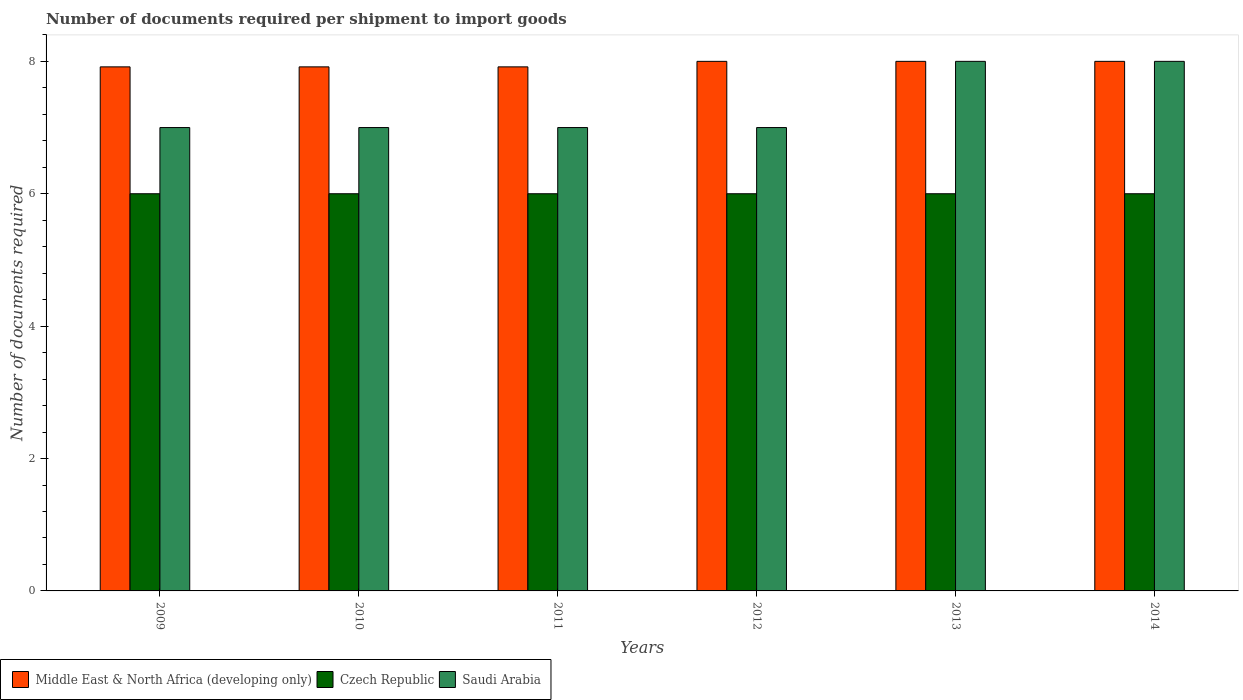How many different coloured bars are there?
Provide a succinct answer. 3. Are the number of bars per tick equal to the number of legend labels?
Your answer should be very brief. Yes. Are the number of bars on each tick of the X-axis equal?
Offer a very short reply. Yes. How many bars are there on the 3rd tick from the right?
Your answer should be very brief. 3. In how many cases, is the number of bars for a given year not equal to the number of legend labels?
Give a very brief answer. 0. What is the number of documents required per shipment to import goods in Middle East & North Africa (developing only) in 2010?
Provide a succinct answer. 7.92. Across all years, what is the maximum number of documents required per shipment to import goods in Middle East & North Africa (developing only)?
Make the answer very short. 8. Across all years, what is the minimum number of documents required per shipment to import goods in Middle East & North Africa (developing only)?
Keep it short and to the point. 7.92. In which year was the number of documents required per shipment to import goods in Czech Republic minimum?
Ensure brevity in your answer.  2009. What is the total number of documents required per shipment to import goods in Saudi Arabia in the graph?
Provide a succinct answer. 44. What is the difference between the number of documents required per shipment to import goods in Middle East & North Africa (developing only) in 2010 and the number of documents required per shipment to import goods in Saudi Arabia in 2009?
Keep it short and to the point. 0.92. What is the average number of documents required per shipment to import goods in Middle East & North Africa (developing only) per year?
Make the answer very short. 7.96. In the year 2011, what is the difference between the number of documents required per shipment to import goods in Middle East & North Africa (developing only) and number of documents required per shipment to import goods in Czech Republic?
Your answer should be compact. 1.92. What is the ratio of the number of documents required per shipment to import goods in Czech Republic in 2010 to that in 2012?
Ensure brevity in your answer.  1. Is the difference between the number of documents required per shipment to import goods in Middle East & North Africa (developing only) in 2009 and 2011 greater than the difference between the number of documents required per shipment to import goods in Czech Republic in 2009 and 2011?
Offer a terse response. No. In how many years, is the number of documents required per shipment to import goods in Saudi Arabia greater than the average number of documents required per shipment to import goods in Saudi Arabia taken over all years?
Make the answer very short. 2. What does the 2nd bar from the left in 2012 represents?
Provide a short and direct response. Czech Republic. What does the 3rd bar from the right in 2012 represents?
Offer a terse response. Middle East & North Africa (developing only). Is it the case that in every year, the sum of the number of documents required per shipment to import goods in Middle East & North Africa (developing only) and number of documents required per shipment to import goods in Czech Republic is greater than the number of documents required per shipment to import goods in Saudi Arabia?
Offer a very short reply. Yes. Are all the bars in the graph horizontal?
Ensure brevity in your answer.  No. Where does the legend appear in the graph?
Keep it short and to the point. Bottom left. How many legend labels are there?
Provide a short and direct response. 3. How are the legend labels stacked?
Your answer should be compact. Horizontal. What is the title of the graph?
Provide a short and direct response. Number of documents required per shipment to import goods. What is the label or title of the X-axis?
Make the answer very short. Years. What is the label or title of the Y-axis?
Your answer should be compact. Number of documents required. What is the Number of documents required in Middle East & North Africa (developing only) in 2009?
Make the answer very short. 7.92. What is the Number of documents required of Czech Republic in 2009?
Provide a short and direct response. 6. What is the Number of documents required of Middle East & North Africa (developing only) in 2010?
Your answer should be very brief. 7.92. What is the Number of documents required of Czech Republic in 2010?
Ensure brevity in your answer.  6. What is the Number of documents required of Middle East & North Africa (developing only) in 2011?
Provide a short and direct response. 7.92. What is the Number of documents required of Czech Republic in 2011?
Your response must be concise. 6. What is the Number of documents required in Middle East & North Africa (developing only) in 2014?
Provide a short and direct response. 8. What is the Number of documents required in Czech Republic in 2014?
Give a very brief answer. 6. Across all years, what is the maximum Number of documents required in Middle East & North Africa (developing only)?
Your response must be concise. 8. Across all years, what is the maximum Number of documents required of Czech Republic?
Offer a terse response. 6. Across all years, what is the minimum Number of documents required in Middle East & North Africa (developing only)?
Offer a terse response. 7.92. What is the total Number of documents required in Middle East & North Africa (developing only) in the graph?
Give a very brief answer. 47.75. What is the total Number of documents required of Czech Republic in the graph?
Keep it short and to the point. 36. What is the total Number of documents required in Saudi Arabia in the graph?
Ensure brevity in your answer.  44. What is the difference between the Number of documents required of Czech Republic in 2009 and that in 2010?
Offer a very short reply. 0. What is the difference between the Number of documents required of Saudi Arabia in 2009 and that in 2010?
Provide a short and direct response. 0. What is the difference between the Number of documents required in Czech Republic in 2009 and that in 2011?
Give a very brief answer. 0. What is the difference between the Number of documents required of Saudi Arabia in 2009 and that in 2011?
Your answer should be compact. 0. What is the difference between the Number of documents required of Middle East & North Africa (developing only) in 2009 and that in 2012?
Ensure brevity in your answer.  -0.08. What is the difference between the Number of documents required of Middle East & North Africa (developing only) in 2009 and that in 2013?
Provide a short and direct response. -0.08. What is the difference between the Number of documents required in Middle East & North Africa (developing only) in 2009 and that in 2014?
Give a very brief answer. -0.08. What is the difference between the Number of documents required of Czech Republic in 2009 and that in 2014?
Keep it short and to the point. 0. What is the difference between the Number of documents required of Saudi Arabia in 2009 and that in 2014?
Provide a succinct answer. -1. What is the difference between the Number of documents required of Czech Republic in 2010 and that in 2011?
Your answer should be very brief. 0. What is the difference between the Number of documents required of Middle East & North Africa (developing only) in 2010 and that in 2012?
Provide a succinct answer. -0.08. What is the difference between the Number of documents required of Czech Republic in 2010 and that in 2012?
Your response must be concise. 0. What is the difference between the Number of documents required in Middle East & North Africa (developing only) in 2010 and that in 2013?
Your answer should be compact. -0.08. What is the difference between the Number of documents required in Saudi Arabia in 2010 and that in 2013?
Offer a very short reply. -1. What is the difference between the Number of documents required in Middle East & North Africa (developing only) in 2010 and that in 2014?
Ensure brevity in your answer.  -0.08. What is the difference between the Number of documents required of Czech Republic in 2010 and that in 2014?
Provide a short and direct response. 0. What is the difference between the Number of documents required of Middle East & North Africa (developing only) in 2011 and that in 2012?
Ensure brevity in your answer.  -0.08. What is the difference between the Number of documents required in Middle East & North Africa (developing only) in 2011 and that in 2013?
Provide a short and direct response. -0.08. What is the difference between the Number of documents required in Czech Republic in 2011 and that in 2013?
Provide a succinct answer. 0. What is the difference between the Number of documents required in Middle East & North Africa (developing only) in 2011 and that in 2014?
Ensure brevity in your answer.  -0.08. What is the difference between the Number of documents required of Czech Republic in 2011 and that in 2014?
Provide a short and direct response. 0. What is the difference between the Number of documents required of Czech Republic in 2012 and that in 2013?
Offer a very short reply. 0. What is the difference between the Number of documents required of Saudi Arabia in 2012 and that in 2014?
Offer a very short reply. -1. What is the difference between the Number of documents required in Middle East & North Africa (developing only) in 2009 and the Number of documents required in Czech Republic in 2010?
Make the answer very short. 1.92. What is the difference between the Number of documents required of Middle East & North Africa (developing only) in 2009 and the Number of documents required of Saudi Arabia in 2010?
Your response must be concise. 0.92. What is the difference between the Number of documents required in Czech Republic in 2009 and the Number of documents required in Saudi Arabia in 2010?
Provide a succinct answer. -1. What is the difference between the Number of documents required in Middle East & North Africa (developing only) in 2009 and the Number of documents required in Czech Republic in 2011?
Your answer should be compact. 1.92. What is the difference between the Number of documents required in Middle East & North Africa (developing only) in 2009 and the Number of documents required in Czech Republic in 2012?
Your answer should be compact. 1.92. What is the difference between the Number of documents required in Czech Republic in 2009 and the Number of documents required in Saudi Arabia in 2012?
Your response must be concise. -1. What is the difference between the Number of documents required in Middle East & North Africa (developing only) in 2009 and the Number of documents required in Czech Republic in 2013?
Offer a very short reply. 1.92. What is the difference between the Number of documents required in Middle East & North Africa (developing only) in 2009 and the Number of documents required in Saudi Arabia in 2013?
Your answer should be very brief. -0.08. What is the difference between the Number of documents required in Middle East & North Africa (developing only) in 2009 and the Number of documents required in Czech Republic in 2014?
Give a very brief answer. 1.92. What is the difference between the Number of documents required of Middle East & North Africa (developing only) in 2009 and the Number of documents required of Saudi Arabia in 2014?
Give a very brief answer. -0.08. What is the difference between the Number of documents required in Middle East & North Africa (developing only) in 2010 and the Number of documents required in Czech Republic in 2011?
Offer a very short reply. 1.92. What is the difference between the Number of documents required in Middle East & North Africa (developing only) in 2010 and the Number of documents required in Saudi Arabia in 2011?
Offer a terse response. 0.92. What is the difference between the Number of documents required in Middle East & North Africa (developing only) in 2010 and the Number of documents required in Czech Republic in 2012?
Give a very brief answer. 1.92. What is the difference between the Number of documents required of Czech Republic in 2010 and the Number of documents required of Saudi Arabia in 2012?
Your answer should be very brief. -1. What is the difference between the Number of documents required of Middle East & North Africa (developing only) in 2010 and the Number of documents required of Czech Republic in 2013?
Offer a terse response. 1.92. What is the difference between the Number of documents required in Middle East & North Africa (developing only) in 2010 and the Number of documents required in Saudi Arabia in 2013?
Your response must be concise. -0.08. What is the difference between the Number of documents required of Czech Republic in 2010 and the Number of documents required of Saudi Arabia in 2013?
Keep it short and to the point. -2. What is the difference between the Number of documents required in Middle East & North Africa (developing only) in 2010 and the Number of documents required in Czech Republic in 2014?
Ensure brevity in your answer.  1.92. What is the difference between the Number of documents required in Middle East & North Africa (developing only) in 2010 and the Number of documents required in Saudi Arabia in 2014?
Give a very brief answer. -0.08. What is the difference between the Number of documents required in Czech Republic in 2010 and the Number of documents required in Saudi Arabia in 2014?
Provide a short and direct response. -2. What is the difference between the Number of documents required of Middle East & North Africa (developing only) in 2011 and the Number of documents required of Czech Republic in 2012?
Your answer should be compact. 1.92. What is the difference between the Number of documents required of Middle East & North Africa (developing only) in 2011 and the Number of documents required of Czech Republic in 2013?
Your answer should be compact. 1.92. What is the difference between the Number of documents required of Middle East & North Africa (developing only) in 2011 and the Number of documents required of Saudi Arabia in 2013?
Provide a succinct answer. -0.08. What is the difference between the Number of documents required in Czech Republic in 2011 and the Number of documents required in Saudi Arabia in 2013?
Make the answer very short. -2. What is the difference between the Number of documents required in Middle East & North Africa (developing only) in 2011 and the Number of documents required in Czech Republic in 2014?
Provide a succinct answer. 1.92. What is the difference between the Number of documents required of Middle East & North Africa (developing only) in 2011 and the Number of documents required of Saudi Arabia in 2014?
Your response must be concise. -0.08. What is the difference between the Number of documents required in Czech Republic in 2011 and the Number of documents required in Saudi Arabia in 2014?
Your response must be concise. -2. What is the difference between the Number of documents required in Middle East & North Africa (developing only) in 2012 and the Number of documents required in Czech Republic in 2013?
Keep it short and to the point. 2. What is the difference between the Number of documents required of Middle East & North Africa (developing only) in 2012 and the Number of documents required of Saudi Arabia in 2013?
Ensure brevity in your answer.  0. What is the difference between the Number of documents required in Czech Republic in 2012 and the Number of documents required in Saudi Arabia in 2013?
Provide a short and direct response. -2. What is the difference between the Number of documents required in Czech Republic in 2012 and the Number of documents required in Saudi Arabia in 2014?
Offer a very short reply. -2. What is the difference between the Number of documents required of Middle East & North Africa (developing only) in 2013 and the Number of documents required of Czech Republic in 2014?
Your answer should be compact. 2. What is the average Number of documents required in Middle East & North Africa (developing only) per year?
Give a very brief answer. 7.96. What is the average Number of documents required in Czech Republic per year?
Make the answer very short. 6. What is the average Number of documents required in Saudi Arabia per year?
Make the answer very short. 7.33. In the year 2009, what is the difference between the Number of documents required in Middle East & North Africa (developing only) and Number of documents required in Czech Republic?
Provide a succinct answer. 1.92. In the year 2009, what is the difference between the Number of documents required in Middle East & North Africa (developing only) and Number of documents required in Saudi Arabia?
Give a very brief answer. 0.92. In the year 2009, what is the difference between the Number of documents required of Czech Republic and Number of documents required of Saudi Arabia?
Offer a very short reply. -1. In the year 2010, what is the difference between the Number of documents required in Middle East & North Africa (developing only) and Number of documents required in Czech Republic?
Ensure brevity in your answer.  1.92. In the year 2010, what is the difference between the Number of documents required of Middle East & North Africa (developing only) and Number of documents required of Saudi Arabia?
Offer a very short reply. 0.92. In the year 2011, what is the difference between the Number of documents required in Middle East & North Africa (developing only) and Number of documents required in Czech Republic?
Offer a very short reply. 1.92. In the year 2012, what is the difference between the Number of documents required of Middle East & North Africa (developing only) and Number of documents required of Saudi Arabia?
Give a very brief answer. 1. In the year 2012, what is the difference between the Number of documents required of Czech Republic and Number of documents required of Saudi Arabia?
Ensure brevity in your answer.  -1. In the year 2013, what is the difference between the Number of documents required in Middle East & North Africa (developing only) and Number of documents required in Saudi Arabia?
Your answer should be very brief. 0. In the year 2014, what is the difference between the Number of documents required of Middle East & North Africa (developing only) and Number of documents required of Saudi Arabia?
Offer a very short reply. 0. What is the ratio of the Number of documents required in Middle East & North Africa (developing only) in 2009 to that in 2010?
Make the answer very short. 1. What is the ratio of the Number of documents required in Czech Republic in 2009 to that in 2010?
Offer a very short reply. 1. What is the ratio of the Number of documents required of Saudi Arabia in 2009 to that in 2010?
Your answer should be compact. 1. What is the ratio of the Number of documents required in Middle East & North Africa (developing only) in 2009 to that in 2011?
Make the answer very short. 1. What is the ratio of the Number of documents required of Middle East & North Africa (developing only) in 2009 to that in 2013?
Give a very brief answer. 0.99. What is the ratio of the Number of documents required of Czech Republic in 2009 to that in 2013?
Offer a terse response. 1. What is the ratio of the Number of documents required in Saudi Arabia in 2009 to that in 2013?
Offer a terse response. 0.88. What is the ratio of the Number of documents required in Middle East & North Africa (developing only) in 2009 to that in 2014?
Offer a very short reply. 0.99. What is the ratio of the Number of documents required in Czech Republic in 2009 to that in 2014?
Keep it short and to the point. 1. What is the ratio of the Number of documents required in Saudi Arabia in 2009 to that in 2014?
Make the answer very short. 0.88. What is the ratio of the Number of documents required in Czech Republic in 2010 to that in 2011?
Your answer should be very brief. 1. What is the ratio of the Number of documents required of Czech Republic in 2010 to that in 2012?
Provide a short and direct response. 1. What is the ratio of the Number of documents required in Saudi Arabia in 2010 to that in 2012?
Give a very brief answer. 1. What is the ratio of the Number of documents required of Middle East & North Africa (developing only) in 2010 to that in 2013?
Your answer should be very brief. 0.99. What is the ratio of the Number of documents required in Czech Republic in 2010 to that in 2013?
Offer a terse response. 1. What is the ratio of the Number of documents required of Middle East & North Africa (developing only) in 2010 to that in 2014?
Keep it short and to the point. 0.99. What is the ratio of the Number of documents required in Saudi Arabia in 2010 to that in 2014?
Give a very brief answer. 0.88. What is the ratio of the Number of documents required of Czech Republic in 2011 to that in 2012?
Offer a terse response. 1. What is the ratio of the Number of documents required in Saudi Arabia in 2011 to that in 2012?
Offer a very short reply. 1. What is the ratio of the Number of documents required in Middle East & North Africa (developing only) in 2011 to that in 2013?
Make the answer very short. 0.99. What is the ratio of the Number of documents required in Middle East & North Africa (developing only) in 2012 to that in 2013?
Provide a succinct answer. 1. What is the ratio of the Number of documents required of Czech Republic in 2012 to that in 2013?
Your answer should be very brief. 1. What is the ratio of the Number of documents required of Saudi Arabia in 2012 to that in 2013?
Provide a short and direct response. 0.88. What is the ratio of the Number of documents required in Middle East & North Africa (developing only) in 2013 to that in 2014?
Your answer should be compact. 1. What is the ratio of the Number of documents required in Czech Republic in 2013 to that in 2014?
Make the answer very short. 1. What is the difference between the highest and the second highest Number of documents required of Czech Republic?
Your answer should be very brief. 0. What is the difference between the highest and the second highest Number of documents required of Saudi Arabia?
Give a very brief answer. 0. What is the difference between the highest and the lowest Number of documents required in Middle East & North Africa (developing only)?
Provide a short and direct response. 0.08. What is the difference between the highest and the lowest Number of documents required of Czech Republic?
Give a very brief answer. 0. 